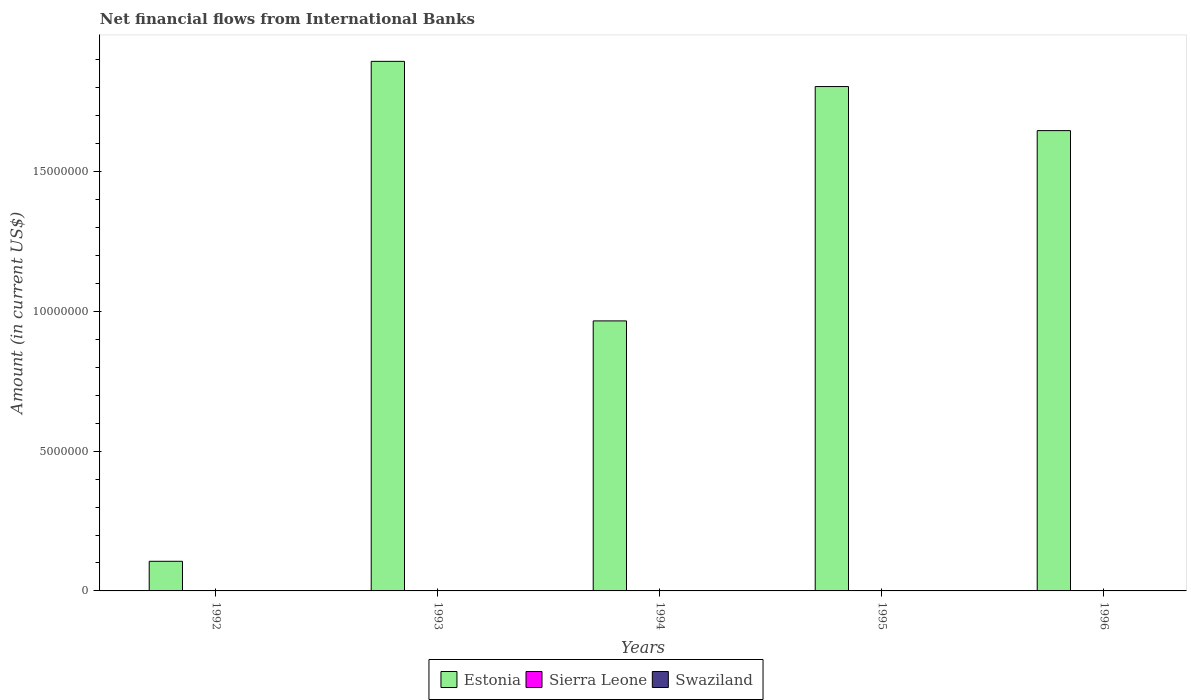How many different coloured bars are there?
Keep it short and to the point. 1. Are the number of bars per tick equal to the number of legend labels?
Your answer should be very brief. No. What is the label of the 5th group of bars from the left?
Your response must be concise. 1996. In how many cases, is the number of bars for a given year not equal to the number of legend labels?
Keep it short and to the point. 5. What is the net financial aid flows in Swaziland in 1993?
Offer a very short reply. 0. Across all years, what is the maximum net financial aid flows in Estonia?
Offer a very short reply. 1.89e+07. Across all years, what is the minimum net financial aid flows in Estonia?
Your answer should be very brief. 1.06e+06. What is the total net financial aid flows in Swaziland in the graph?
Your answer should be compact. 0. What is the difference between the net financial aid flows in Estonia in 1995 and that in 1996?
Provide a short and direct response. 1.58e+06. What is the ratio of the net financial aid flows in Estonia in 1995 to that in 1996?
Provide a short and direct response. 1.1. What is the difference between the highest and the second highest net financial aid flows in Estonia?
Offer a very short reply. 9.02e+05. What is the difference between the highest and the lowest net financial aid flows in Estonia?
Your answer should be very brief. 1.79e+07. In how many years, is the net financial aid flows in Sierra Leone greater than the average net financial aid flows in Sierra Leone taken over all years?
Keep it short and to the point. 0. Is the sum of the net financial aid flows in Estonia in 1995 and 1996 greater than the maximum net financial aid flows in Swaziland across all years?
Your answer should be compact. Yes. Is it the case that in every year, the sum of the net financial aid flows in Sierra Leone and net financial aid flows in Swaziland is greater than the net financial aid flows in Estonia?
Give a very brief answer. No. How many bars are there?
Give a very brief answer. 5. Does the graph contain any zero values?
Make the answer very short. Yes. Does the graph contain grids?
Ensure brevity in your answer.  No. Where does the legend appear in the graph?
Provide a short and direct response. Bottom center. What is the title of the graph?
Your answer should be very brief. Net financial flows from International Banks. What is the Amount (in current US$) in Estonia in 1992?
Your answer should be compact. 1.06e+06. What is the Amount (in current US$) in Sierra Leone in 1992?
Provide a succinct answer. 0. What is the Amount (in current US$) of Estonia in 1993?
Ensure brevity in your answer.  1.89e+07. What is the Amount (in current US$) of Sierra Leone in 1993?
Offer a very short reply. 0. What is the Amount (in current US$) in Swaziland in 1993?
Provide a succinct answer. 0. What is the Amount (in current US$) in Estonia in 1994?
Offer a very short reply. 9.66e+06. What is the Amount (in current US$) of Sierra Leone in 1994?
Provide a short and direct response. 0. What is the Amount (in current US$) in Swaziland in 1994?
Make the answer very short. 0. What is the Amount (in current US$) of Estonia in 1995?
Offer a very short reply. 1.80e+07. What is the Amount (in current US$) of Sierra Leone in 1995?
Your response must be concise. 0. What is the Amount (in current US$) of Estonia in 1996?
Provide a short and direct response. 1.65e+07. What is the Amount (in current US$) in Sierra Leone in 1996?
Your answer should be very brief. 0. What is the Amount (in current US$) of Swaziland in 1996?
Offer a terse response. 0. Across all years, what is the maximum Amount (in current US$) of Estonia?
Your answer should be very brief. 1.89e+07. Across all years, what is the minimum Amount (in current US$) of Estonia?
Your answer should be compact. 1.06e+06. What is the total Amount (in current US$) in Estonia in the graph?
Ensure brevity in your answer.  6.42e+07. What is the total Amount (in current US$) in Sierra Leone in the graph?
Give a very brief answer. 0. What is the difference between the Amount (in current US$) in Estonia in 1992 and that in 1993?
Your answer should be compact. -1.79e+07. What is the difference between the Amount (in current US$) in Estonia in 1992 and that in 1994?
Provide a succinct answer. -8.60e+06. What is the difference between the Amount (in current US$) of Estonia in 1992 and that in 1995?
Give a very brief answer. -1.70e+07. What is the difference between the Amount (in current US$) of Estonia in 1992 and that in 1996?
Provide a succinct answer. -1.54e+07. What is the difference between the Amount (in current US$) in Estonia in 1993 and that in 1994?
Make the answer very short. 9.28e+06. What is the difference between the Amount (in current US$) of Estonia in 1993 and that in 1995?
Your answer should be very brief. 9.02e+05. What is the difference between the Amount (in current US$) of Estonia in 1993 and that in 1996?
Give a very brief answer. 2.48e+06. What is the difference between the Amount (in current US$) of Estonia in 1994 and that in 1995?
Your answer should be compact. -8.38e+06. What is the difference between the Amount (in current US$) of Estonia in 1994 and that in 1996?
Give a very brief answer. -6.81e+06. What is the difference between the Amount (in current US$) of Estonia in 1995 and that in 1996?
Keep it short and to the point. 1.58e+06. What is the average Amount (in current US$) in Estonia per year?
Make the answer very short. 1.28e+07. What is the average Amount (in current US$) of Sierra Leone per year?
Offer a very short reply. 0. What is the ratio of the Amount (in current US$) of Estonia in 1992 to that in 1993?
Give a very brief answer. 0.06. What is the ratio of the Amount (in current US$) in Estonia in 1992 to that in 1994?
Make the answer very short. 0.11. What is the ratio of the Amount (in current US$) in Estonia in 1992 to that in 1995?
Provide a succinct answer. 0.06. What is the ratio of the Amount (in current US$) of Estonia in 1992 to that in 1996?
Keep it short and to the point. 0.06. What is the ratio of the Amount (in current US$) in Estonia in 1993 to that in 1994?
Your response must be concise. 1.96. What is the ratio of the Amount (in current US$) of Estonia in 1993 to that in 1995?
Your response must be concise. 1.05. What is the ratio of the Amount (in current US$) of Estonia in 1993 to that in 1996?
Offer a terse response. 1.15. What is the ratio of the Amount (in current US$) of Estonia in 1994 to that in 1995?
Make the answer very short. 0.54. What is the ratio of the Amount (in current US$) of Estonia in 1994 to that in 1996?
Offer a terse response. 0.59. What is the ratio of the Amount (in current US$) in Estonia in 1995 to that in 1996?
Give a very brief answer. 1.1. What is the difference between the highest and the second highest Amount (in current US$) of Estonia?
Give a very brief answer. 9.02e+05. What is the difference between the highest and the lowest Amount (in current US$) of Estonia?
Ensure brevity in your answer.  1.79e+07. 